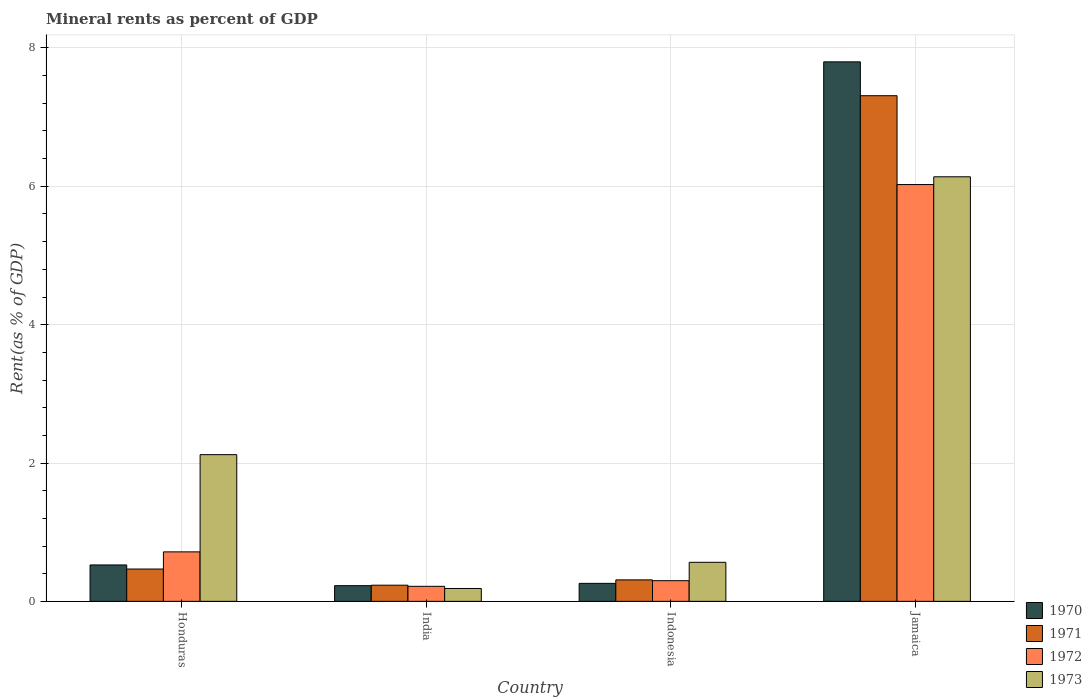How many different coloured bars are there?
Provide a short and direct response. 4. How many groups of bars are there?
Offer a terse response. 4. Are the number of bars on each tick of the X-axis equal?
Keep it short and to the point. Yes. How many bars are there on the 4th tick from the right?
Offer a terse response. 4. What is the label of the 3rd group of bars from the left?
Your answer should be compact. Indonesia. What is the mineral rent in 1972 in Indonesia?
Give a very brief answer. 0.3. Across all countries, what is the maximum mineral rent in 1973?
Offer a terse response. 6.14. Across all countries, what is the minimum mineral rent in 1972?
Ensure brevity in your answer.  0.22. In which country was the mineral rent in 1970 maximum?
Your response must be concise. Jamaica. In which country was the mineral rent in 1971 minimum?
Offer a terse response. India. What is the total mineral rent in 1973 in the graph?
Provide a short and direct response. 9.01. What is the difference between the mineral rent in 1973 in Indonesia and that in Jamaica?
Offer a terse response. -5.57. What is the difference between the mineral rent in 1972 in Honduras and the mineral rent in 1970 in Indonesia?
Give a very brief answer. 0.46. What is the average mineral rent in 1973 per country?
Keep it short and to the point. 2.25. What is the difference between the mineral rent of/in 1971 and mineral rent of/in 1973 in Honduras?
Provide a succinct answer. -1.65. In how many countries, is the mineral rent in 1972 greater than 4.4 %?
Your answer should be compact. 1. What is the ratio of the mineral rent in 1970 in Honduras to that in India?
Provide a succinct answer. 2.32. What is the difference between the highest and the second highest mineral rent in 1973?
Offer a terse response. -1.56. What is the difference between the highest and the lowest mineral rent in 1972?
Your answer should be very brief. 5.81. Is the sum of the mineral rent in 1972 in India and Indonesia greater than the maximum mineral rent in 1971 across all countries?
Offer a very short reply. No. Is it the case that in every country, the sum of the mineral rent in 1971 and mineral rent in 1970 is greater than the sum of mineral rent in 1973 and mineral rent in 1972?
Ensure brevity in your answer.  No. What does the 3rd bar from the left in Indonesia represents?
Provide a succinct answer. 1972. What does the 4th bar from the right in Indonesia represents?
Provide a short and direct response. 1970. How many countries are there in the graph?
Your response must be concise. 4. Does the graph contain any zero values?
Ensure brevity in your answer.  No. How many legend labels are there?
Your response must be concise. 4. What is the title of the graph?
Offer a very short reply. Mineral rents as percent of GDP. What is the label or title of the Y-axis?
Your answer should be compact. Rent(as % of GDP). What is the Rent(as % of GDP) of 1970 in Honduras?
Make the answer very short. 0.53. What is the Rent(as % of GDP) of 1971 in Honduras?
Offer a very short reply. 0.47. What is the Rent(as % of GDP) in 1972 in Honduras?
Offer a very short reply. 0.72. What is the Rent(as % of GDP) of 1973 in Honduras?
Provide a short and direct response. 2.12. What is the Rent(as % of GDP) of 1970 in India?
Provide a succinct answer. 0.23. What is the Rent(as % of GDP) in 1971 in India?
Make the answer very short. 0.23. What is the Rent(as % of GDP) in 1972 in India?
Your response must be concise. 0.22. What is the Rent(as % of GDP) in 1973 in India?
Offer a very short reply. 0.19. What is the Rent(as % of GDP) in 1970 in Indonesia?
Make the answer very short. 0.26. What is the Rent(as % of GDP) of 1971 in Indonesia?
Keep it short and to the point. 0.31. What is the Rent(as % of GDP) of 1972 in Indonesia?
Keep it short and to the point. 0.3. What is the Rent(as % of GDP) in 1973 in Indonesia?
Ensure brevity in your answer.  0.56. What is the Rent(as % of GDP) in 1970 in Jamaica?
Offer a very short reply. 7.8. What is the Rent(as % of GDP) in 1971 in Jamaica?
Keep it short and to the point. 7.31. What is the Rent(as % of GDP) in 1972 in Jamaica?
Offer a terse response. 6.03. What is the Rent(as % of GDP) in 1973 in Jamaica?
Give a very brief answer. 6.14. Across all countries, what is the maximum Rent(as % of GDP) of 1970?
Offer a very short reply. 7.8. Across all countries, what is the maximum Rent(as % of GDP) of 1971?
Your answer should be very brief. 7.31. Across all countries, what is the maximum Rent(as % of GDP) of 1972?
Provide a succinct answer. 6.03. Across all countries, what is the maximum Rent(as % of GDP) in 1973?
Keep it short and to the point. 6.14. Across all countries, what is the minimum Rent(as % of GDP) of 1970?
Your answer should be compact. 0.23. Across all countries, what is the minimum Rent(as % of GDP) in 1971?
Make the answer very short. 0.23. Across all countries, what is the minimum Rent(as % of GDP) in 1972?
Your answer should be very brief. 0.22. Across all countries, what is the minimum Rent(as % of GDP) in 1973?
Make the answer very short. 0.19. What is the total Rent(as % of GDP) in 1970 in the graph?
Offer a very short reply. 8.81. What is the total Rent(as % of GDP) in 1971 in the graph?
Your answer should be very brief. 8.32. What is the total Rent(as % of GDP) in 1972 in the graph?
Your response must be concise. 7.26. What is the total Rent(as % of GDP) of 1973 in the graph?
Provide a short and direct response. 9.01. What is the difference between the Rent(as % of GDP) of 1970 in Honduras and that in India?
Your answer should be very brief. 0.3. What is the difference between the Rent(as % of GDP) in 1971 in Honduras and that in India?
Make the answer very short. 0.23. What is the difference between the Rent(as % of GDP) of 1972 in Honduras and that in India?
Provide a short and direct response. 0.5. What is the difference between the Rent(as % of GDP) of 1973 in Honduras and that in India?
Ensure brevity in your answer.  1.94. What is the difference between the Rent(as % of GDP) of 1970 in Honduras and that in Indonesia?
Your answer should be very brief. 0.27. What is the difference between the Rent(as % of GDP) of 1971 in Honduras and that in Indonesia?
Provide a succinct answer. 0.16. What is the difference between the Rent(as % of GDP) in 1972 in Honduras and that in Indonesia?
Make the answer very short. 0.42. What is the difference between the Rent(as % of GDP) of 1973 in Honduras and that in Indonesia?
Make the answer very short. 1.56. What is the difference between the Rent(as % of GDP) of 1970 in Honduras and that in Jamaica?
Keep it short and to the point. -7.27. What is the difference between the Rent(as % of GDP) in 1971 in Honduras and that in Jamaica?
Ensure brevity in your answer.  -6.84. What is the difference between the Rent(as % of GDP) in 1972 in Honduras and that in Jamaica?
Provide a succinct answer. -5.31. What is the difference between the Rent(as % of GDP) of 1973 in Honduras and that in Jamaica?
Make the answer very short. -4.02. What is the difference between the Rent(as % of GDP) in 1970 in India and that in Indonesia?
Offer a terse response. -0.03. What is the difference between the Rent(as % of GDP) in 1971 in India and that in Indonesia?
Provide a short and direct response. -0.08. What is the difference between the Rent(as % of GDP) in 1972 in India and that in Indonesia?
Keep it short and to the point. -0.08. What is the difference between the Rent(as % of GDP) of 1973 in India and that in Indonesia?
Give a very brief answer. -0.38. What is the difference between the Rent(as % of GDP) of 1970 in India and that in Jamaica?
Your answer should be compact. -7.57. What is the difference between the Rent(as % of GDP) in 1971 in India and that in Jamaica?
Offer a very short reply. -7.08. What is the difference between the Rent(as % of GDP) of 1972 in India and that in Jamaica?
Your answer should be very brief. -5.81. What is the difference between the Rent(as % of GDP) in 1973 in India and that in Jamaica?
Your answer should be very brief. -5.95. What is the difference between the Rent(as % of GDP) of 1970 in Indonesia and that in Jamaica?
Make the answer very short. -7.54. What is the difference between the Rent(as % of GDP) of 1971 in Indonesia and that in Jamaica?
Offer a very short reply. -7. What is the difference between the Rent(as % of GDP) of 1972 in Indonesia and that in Jamaica?
Make the answer very short. -5.73. What is the difference between the Rent(as % of GDP) of 1973 in Indonesia and that in Jamaica?
Your answer should be very brief. -5.57. What is the difference between the Rent(as % of GDP) of 1970 in Honduras and the Rent(as % of GDP) of 1971 in India?
Offer a very short reply. 0.29. What is the difference between the Rent(as % of GDP) of 1970 in Honduras and the Rent(as % of GDP) of 1972 in India?
Give a very brief answer. 0.31. What is the difference between the Rent(as % of GDP) in 1970 in Honduras and the Rent(as % of GDP) in 1973 in India?
Make the answer very short. 0.34. What is the difference between the Rent(as % of GDP) in 1971 in Honduras and the Rent(as % of GDP) in 1972 in India?
Provide a succinct answer. 0.25. What is the difference between the Rent(as % of GDP) of 1971 in Honduras and the Rent(as % of GDP) of 1973 in India?
Your answer should be very brief. 0.28. What is the difference between the Rent(as % of GDP) of 1972 in Honduras and the Rent(as % of GDP) of 1973 in India?
Your answer should be very brief. 0.53. What is the difference between the Rent(as % of GDP) in 1970 in Honduras and the Rent(as % of GDP) in 1971 in Indonesia?
Provide a succinct answer. 0.22. What is the difference between the Rent(as % of GDP) in 1970 in Honduras and the Rent(as % of GDP) in 1972 in Indonesia?
Your response must be concise. 0.23. What is the difference between the Rent(as % of GDP) of 1970 in Honduras and the Rent(as % of GDP) of 1973 in Indonesia?
Offer a terse response. -0.04. What is the difference between the Rent(as % of GDP) of 1971 in Honduras and the Rent(as % of GDP) of 1972 in Indonesia?
Make the answer very short. 0.17. What is the difference between the Rent(as % of GDP) in 1971 in Honduras and the Rent(as % of GDP) in 1973 in Indonesia?
Your response must be concise. -0.1. What is the difference between the Rent(as % of GDP) of 1972 in Honduras and the Rent(as % of GDP) of 1973 in Indonesia?
Make the answer very short. 0.15. What is the difference between the Rent(as % of GDP) of 1970 in Honduras and the Rent(as % of GDP) of 1971 in Jamaica?
Provide a succinct answer. -6.78. What is the difference between the Rent(as % of GDP) of 1970 in Honduras and the Rent(as % of GDP) of 1972 in Jamaica?
Your answer should be compact. -5.5. What is the difference between the Rent(as % of GDP) in 1970 in Honduras and the Rent(as % of GDP) in 1973 in Jamaica?
Give a very brief answer. -5.61. What is the difference between the Rent(as % of GDP) in 1971 in Honduras and the Rent(as % of GDP) in 1972 in Jamaica?
Offer a terse response. -5.56. What is the difference between the Rent(as % of GDP) of 1971 in Honduras and the Rent(as % of GDP) of 1973 in Jamaica?
Ensure brevity in your answer.  -5.67. What is the difference between the Rent(as % of GDP) in 1972 in Honduras and the Rent(as % of GDP) in 1973 in Jamaica?
Your response must be concise. -5.42. What is the difference between the Rent(as % of GDP) of 1970 in India and the Rent(as % of GDP) of 1971 in Indonesia?
Keep it short and to the point. -0.08. What is the difference between the Rent(as % of GDP) of 1970 in India and the Rent(as % of GDP) of 1972 in Indonesia?
Give a very brief answer. -0.07. What is the difference between the Rent(as % of GDP) of 1970 in India and the Rent(as % of GDP) of 1973 in Indonesia?
Ensure brevity in your answer.  -0.34. What is the difference between the Rent(as % of GDP) in 1971 in India and the Rent(as % of GDP) in 1972 in Indonesia?
Provide a short and direct response. -0.07. What is the difference between the Rent(as % of GDP) in 1971 in India and the Rent(as % of GDP) in 1973 in Indonesia?
Provide a succinct answer. -0.33. What is the difference between the Rent(as % of GDP) of 1972 in India and the Rent(as % of GDP) of 1973 in Indonesia?
Your answer should be very brief. -0.35. What is the difference between the Rent(as % of GDP) in 1970 in India and the Rent(as % of GDP) in 1971 in Jamaica?
Make the answer very short. -7.08. What is the difference between the Rent(as % of GDP) of 1970 in India and the Rent(as % of GDP) of 1972 in Jamaica?
Your answer should be very brief. -5.8. What is the difference between the Rent(as % of GDP) in 1970 in India and the Rent(as % of GDP) in 1973 in Jamaica?
Ensure brevity in your answer.  -5.91. What is the difference between the Rent(as % of GDP) in 1971 in India and the Rent(as % of GDP) in 1972 in Jamaica?
Your answer should be very brief. -5.79. What is the difference between the Rent(as % of GDP) of 1971 in India and the Rent(as % of GDP) of 1973 in Jamaica?
Offer a very short reply. -5.9. What is the difference between the Rent(as % of GDP) of 1972 in India and the Rent(as % of GDP) of 1973 in Jamaica?
Your answer should be very brief. -5.92. What is the difference between the Rent(as % of GDP) of 1970 in Indonesia and the Rent(as % of GDP) of 1971 in Jamaica?
Provide a succinct answer. -7.05. What is the difference between the Rent(as % of GDP) of 1970 in Indonesia and the Rent(as % of GDP) of 1972 in Jamaica?
Your response must be concise. -5.77. What is the difference between the Rent(as % of GDP) of 1970 in Indonesia and the Rent(as % of GDP) of 1973 in Jamaica?
Keep it short and to the point. -5.88. What is the difference between the Rent(as % of GDP) of 1971 in Indonesia and the Rent(as % of GDP) of 1972 in Jamaica?
Offer a very short reply. -5.72. What is the difference between the Rent(as % of GDP) of 1971 in Indonesia and the Rent(as % of GDP) of 1973 in Jamaica?
Your response must be concise. -5.83. What is the difference between the Rent(as % of GDP) in 1972 in Indonesia and the Rent(as % of GDP) in 1973 in Jamaica?
Provide a succinct answer. -5.84. What is the average Rent(as % of GDP) of 1970 per country?
Make the answer very short. 2.2. What is the average Rent(as % of GDP) of 1971 per country?
Your answer should be compact. 2.08. What is the average Rent(as % of GDP) of 1972 per country?
Your answer should be compact. 1.81. What is the average Rent(as % of GDP) of 1973 per country?
Offer a very short reply. 2.25. What is the difference between the Rent(as % of GDP) in 1970 and Rent(as % of GDP) in 1971 in Honduras?
Keep it short and to the point. 0.06. What is the difference between the Rent(as % of GDP) of 1970 and Rent(as % of GDP) of 1972 in Honduras?
Provide a short and direct response. -0.19. What is the difference between the Rent(as % of GDP) of 1970 and Rent(as % of GDP) of 1973 in Honduras?
Give a very brief answer. -1.59. What is the difference between the Rent(as % of GDP) in 1971 and Rent(as % of GDP) in 1972 in Honduras?
Provide a succinct answer. -0.25. What is the difference between the Rent(as % of GDP) of 1971 and Rent(as % of GDP) of 1973 in Honduras?
Provide a succinct answer. -1.65. What is the difference between the Rent(as % of GDP) in 1972 and Rent(as % of GDP) in 1973 in Honduras?
Your answer should be very brief. -1.41. What is the difference between the Rent(as % of GDP) in 1970 and Rent(as % of GDP) in 1971 in India?
Your answer should be compact. -0.01. What is the difference between the Rent(as % of GDP) of 1970 and Rent(as % of GDP) of 1972 in India?
Offer a very short reply. 0.01. What is the difference between the Rent(as % of GDP) of 1970 and Rent(as % of GDP) of 1973 in India?
Provide a short and direct response. 0.04. What is the difference between the Rent(as % of GDP) in 1971 and Rent(as % of GDP) in 1972 in India?
Offer a very short reply. 0.02. What is the difference between the Rent(as % of GDP) of 1971 and Rent(as % of GDP) of 1973 in India?
Keep it short and to the point. 0.05. What is the difference between the Rent(as % of GDP) of 1972 and Rent(as % of GDP) of 1973 in India?
Give a very brief answer. 0.03. What is the difference between the Rent(as % of GDP) in 1970 and Rent(as % of GDP) in 1971 in Indonesia?
Keep it short and to the point. -0.05. What is the difference between the Rent(as % of GDP) of 1970 and Rent(as % of GDP) of 1972 in Indonesia?
Make the answer very short. -0.04. What is the difference between the Rent(as % of GDP) in 1970 and Rent(as % of GDP) in 1973 in Indonesia?
Your answer should be compact. -0.3. What is the difference between the Rent(as % of GDP) in 1971 and Rent(as % of GDP) in 1972 in Indonesia?
Provide a succinct answer. 0.01. What is the difference between the Rent(as % of GDP) in 1971 and Rent(as % of GDP) in 1973 in Indonesia?
Your answer should be very brief. -0.25. What is the difference between the Rent(as % of GDP) of 1972 and Rent(as % of GDP) of 1973 in Indonesia?
Provide a short and direct response. -0.27. What is the difference between the Rent(as % of GDP) of 1970 and Rent(as % of GDP) of 1971 in Jamaica?
Your answer should be very brief. 0.49. What is the difference between the Rent(as % of GDP) of 1970 and Rent(as % of GDP) of 1972 in Jamaica?
Make the answer very short. 1.77. What is the difference between the Rent(as % of GDP) of 1970 and Rent(as % of GDP) of 1973 in Jamaica?
Your response must be concise. 1.66. What is the difference between the Rent(as % of GDP) of 1971 and Rent(as % of GDP) of 1972 in Jamaica?
Your answer should be compact. 1.28. What is the difference between the Rent(as % of GDP) in 1971 and Rent(as % of GDP) in 1973 in Jamaica?
Your response must be concise. 1.17. What is the difference between the Rent(as % of GDP) in 1972 and Rent(as % of GDP) in 1973 in Jamaica?
Provide a short and direct response. -0.11. What is the ratio of the Rent(as % of GDP) in 1970 in Honduras to that in India?
Your answer should be compact. 2.32. What is the ratio of the Rent(as % of GDP) of 1971 in Honduras to that in India?
Keep it short and to the point. 2. What is the ratio of the Rent(as % of GDP) in 1972 in Honduras to that in India?
Your answer should be very brief. 3.29. What is the ratio of the Rent(as % of GDP) in 1973 in Honduras to that in India?
Give a very brief answer. 11.41. What is the ratio of the Rent(as % of GDP) of 1970 in Honduras to that in Indonesia?
Your response must be concise. 2.02. What is the ratio of the Rent(as % of GDP) in 1971 in Honduras to that in Indonesia?
Give a very brief answer. 1.51. What is the ratio of the Rent(as % of GDP) of 1972 in Honduras to that in Indonesia?
Your answer should be very brief. 2.4. What is the ratio of the Rent(as % of GDP) in 1973 in Honduras to that in Indonesia?
Provide a short and direct response. 3.76. What is the ratio of the Rent(as % of GDP) in 1970 in Honduras to that in Jamaica?
Provide a short and direct response. 0.07. What is the ratio of the Rent(as % of GDP) of 1971 in Honduras to that in Jamaica?
Offer a terse response. 0.06. What is the ratio of the Rent(as % of GDP) of 1972 in Honduras to that in Jamaica?
Give a very brief answer. 0.12. What is the ratio of the Rent(as % of GDP) in 1973 in Honduras to that in Jamaica?
Your answer should be very brief. 0.35. What is the ratio of the Rent(as % of GDP) of 1970 in India to that in Indonesia?
Keep it short and to the point. 0.87. What is the ratio of the Rent(as % of GDP) in 1971 in India to that in Indonesia?
Your response must be concise. 0.75. What is the ratio of the Rent(as % of GDP) in 1972 in India to that in Indonesia?
Your response must be concise. 0.73. What is the ratio of the Rent(as % of GDP) in 1973 in India to that in Indonesia?
Offer a very short reply. 0.33. What is the ratio of the Rent(as % of GDP) in 1970 in India to that in Jamaica?
Ensure brevity in your answer.  0.03. What is the ratio of the Rent(as % of GDP) in 1971 in India to that in Jamaica?
Make the answer very short. 0.03. What is the ratio of the Rent(as % of GDP) in 1972 in India to that in Jamaica?
Your response must be concise. 0.04. What is the ratio of the Rent(as % of GDP) of 1973 in India to that in Jamaica?
Provide a short and direct response. 0.03. What is the ratio of the Rent(as % of GDP) in 1970 in Indonesia to that in Jamaica?
Offer a very short reply. 0.03. What is the ratio of the Rent(as % of GDP) in 1971 in Indonesia to that in Jamaica?
Offer a terse response. 0.04. What is the ratio of the Rent(as % of GDP) of 1972 in Indonesia to that in Jamaica?
Offer a very short reply. 0.05. What is the ratio of the Rent(as % of GDP) in 1973 in Indonesia to that in Jamaica?
Offer a terse response. 0.09. What is the difference between the highest and the second highest Rent(as % of GDP) in 1970?
Offer a very short reply. 7.27. What is the difference between the highest and the second highest Rent(as % of GDP) of 1971?
Give a very brief answer. 6.84. What is the difference between the highest and the second highest Rent(as % of GDP) of 1972?
Provide a succinct answer. 5.31. What is the difference between the highest and the second highest Rent(as % of GDP) of 1973?
Keep it short and to the point. 4.02. What is the difference between the highest and the lowest Rent(as % of GDP) of 1970?
Give a very brief answer. 7.57. What is the difference between the highest and the lowest Rent(as % of GDP) of 1971?
Your response must be concise. 7.08. What is the difference between the highest and the lowest Rent(as % of GDP) in 1972?
Make the answer very short. 5.81. What is the difference between the highest and the lowest Rent(as % of GDP) in 1973?
Make the answer very short. 5.95. 